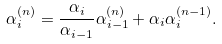Convert formula to latex. <formula><loc_0><loc_0><loc_500><loc_500>\alpha _ { i } ^ { ( n ) } = \frac { \alpha _ { i } } { \alpha _ { i - 1 } } \alpha _ { i - 1 } ^ { ( n ) } + \alpha _ { i } \alpha _ { i } ^ { ( n - 1 ) } .</formula> 